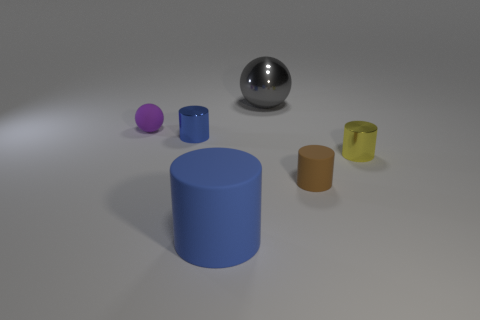Could you infer the purpose of this image? Given the simplicity and organization of the objects, this image might be intended for a visual study of geometry, light, and shadow, or it could serve as a render test for 3D modeling software. 